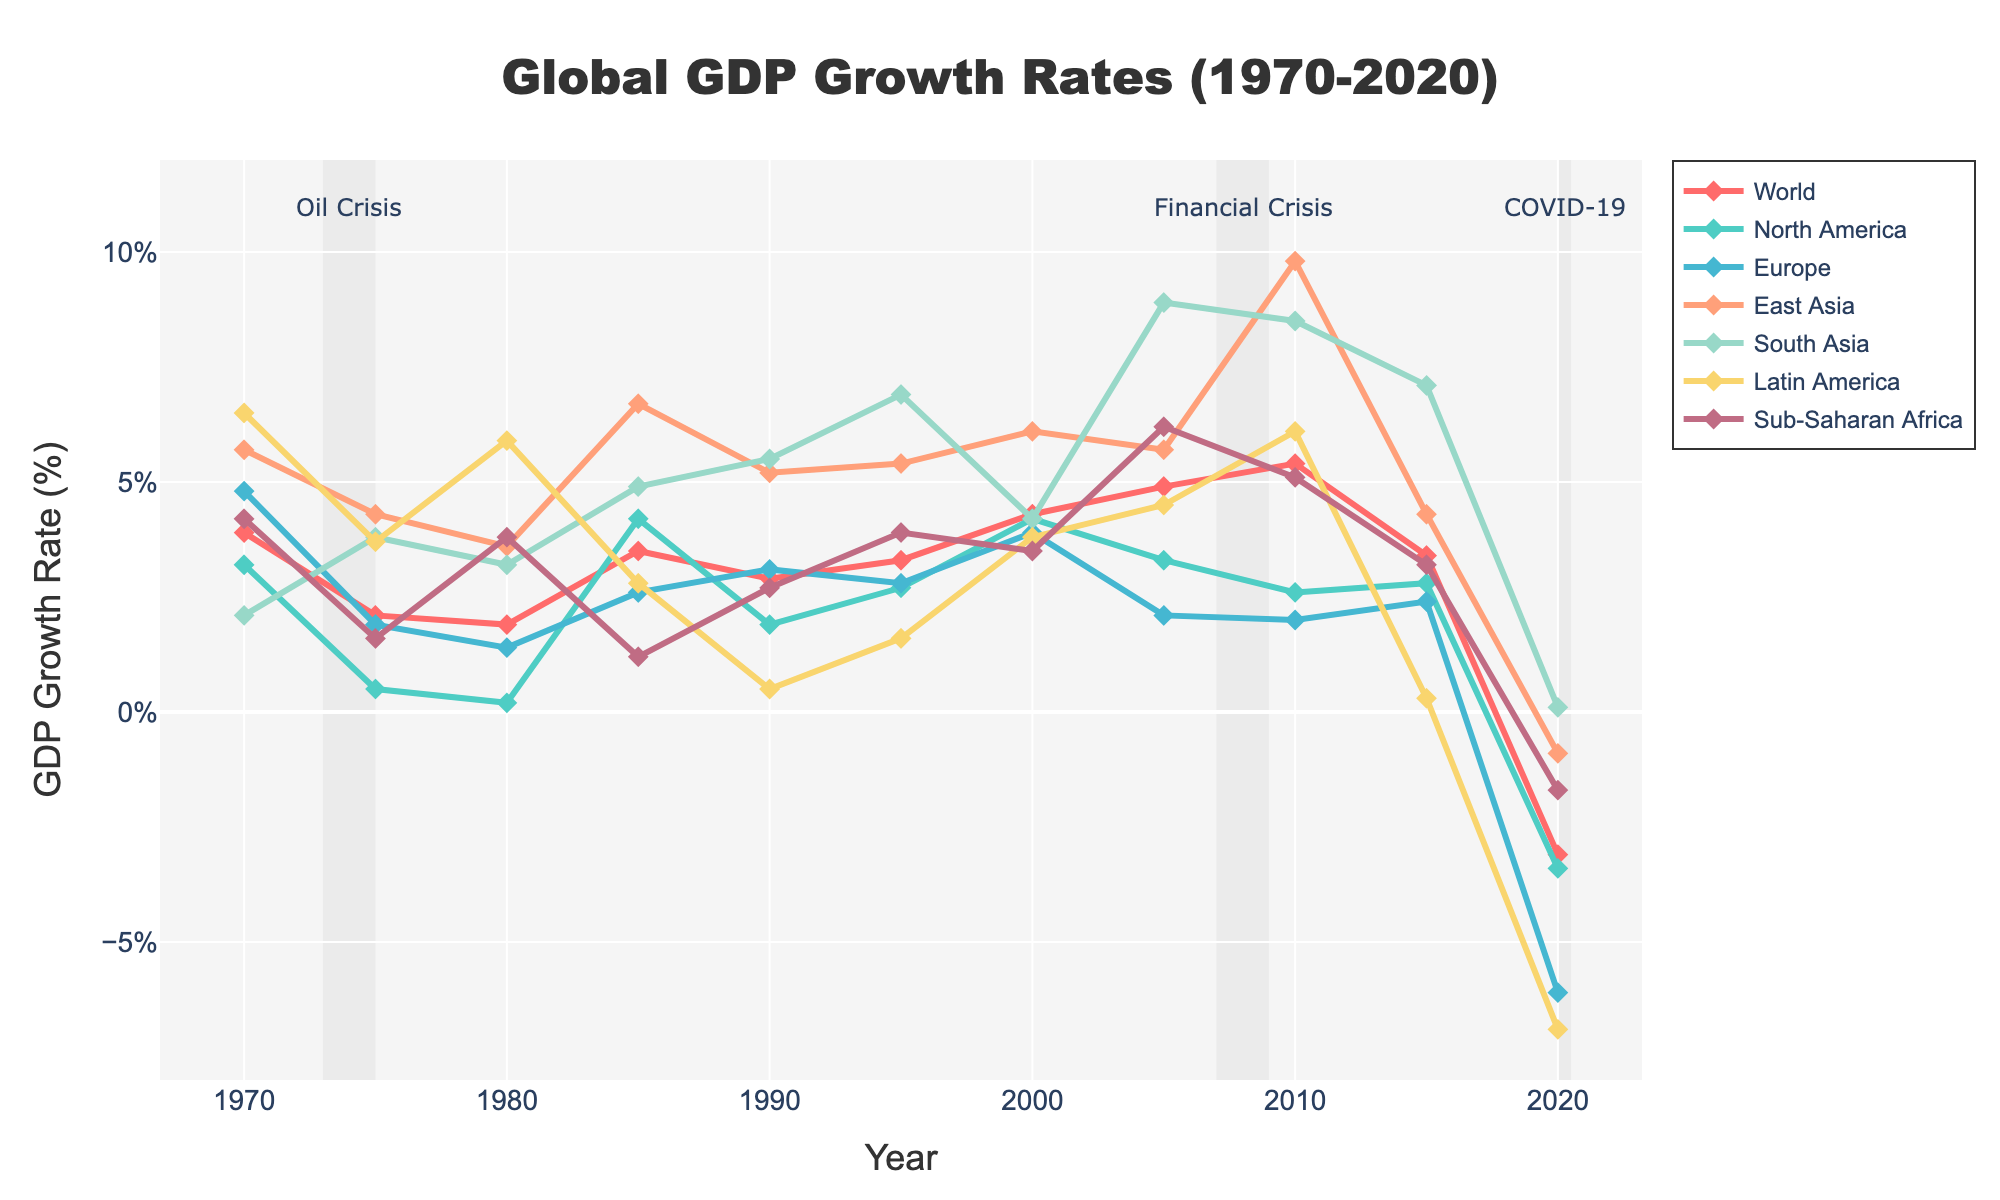How did the GDP growth rates for North America and Europe compare in 1975? In 1975, the GDP growth rate for North America was 0.5%, and for Europe, it was 1.9%. By comparing these two, we see that Europe's GDP growth rate was higher than North America's.
Answer: Europe's GDP growth rate was higher Which region experienced the highest GDP growth rate in 1985? By looking at the GDP growth rates for each region in 1985, we see that East Asia had the highest rate at 6.7%.
Answer: East Asia During the Oil Crisis recession period (1973-1975), how did the world GDP growth rate change? The world GDP growth rate decreased from 3.9% in 1970 to 2.1% in 1975. This indicates a decline in the growth rate during the Oil Crisis.
Answer: It decreased What was the difference in GDP growth rates between South Asia and Sub-Saharan Africa in 2010? In 2010, South Asia had a GDP growth rate of 8.5%, and Sub-Saharan Africa had a rate of 5.1%. The difference between these two rates is 8.5% - 5.1% = 3.4%.
Answer: 3.4% Compare the GDP growth rates for East Asia and Latin America in 2020. In 2020, East Asia had a GDP growth rate of -0.9%, and Latin America had a growth rate of -6.9%. By comparing these, East Asia's rate was higher than Latin America's.
Answer: East Asia's growth rate was higher Identify the region with the lowest GDP growth rate in 2005. Looking at the GDP growth rates in 2005, Europe had the lowest rate at 2.1%.
Answer: Europe How does the GDP growth rate of the world in 2000 compare to that in 2020? The world GDP growth rate in 2000 was 4.3%, while in 2020, it was -3.1%. Comparing these, we see a significant decline in the growth rate by 2020.
Answer: 2000 had a higher growth rate What trend can be observed in South Asia's GDP growth rate from 2005 to 2015? South Asia's GDP growth rate was 8.9% in 2005, 8.5% in 2010, and 7.1% in 2015. This indicates a decreasing trend in the growth rate over these years.
Answer: Decreasing trend Determine the average GDP growth rate of Latin America from 1970 to 2020. To find the average, sum the GDP growth rates for Latin America across the years and divide by the number of data points: (6.5 + 3.7 + 5.9 + 2.8 + 0.5 + 1.6 + 3.8 + 4.5 + 6.1 + 0.3 - 6.9) / 11 = 2.36%.
Answer: 2.36% Which region showed the most significant drop in GDP growth rate from 1970 to 2020? By comparing the GDP growth rates in 1970 and 2020, Europe had a growth rate of 4.8% in 1970 and -6.1% in 2020, showing the most significant drop in rate.
Answer: Europe 